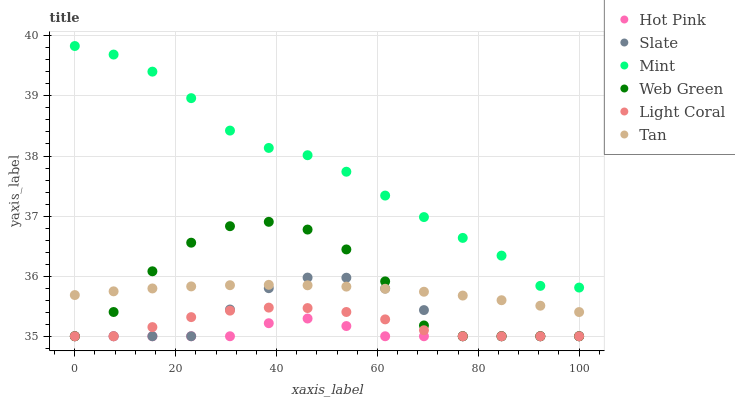Does Hot Pink have the minimum area under the curve?
Answer yes or no. Yes. Does Mint have the maximum area under the curve?
Answer yes or no. Yes. Does Web Green have the minimum area under the curve?
Answer yes or no. No. Does Web Green have the maximum area under the curve?
Answer yes or no. No. Is Tan the smoothest?
Answer yes or no. Yes. Is Web Green the roughest?
Answer yes or no. Yes. Is Hot Pink the smoothest?
Answer yes or no. No. Is Hot Pink the roughest?
Answer yes or no. No. Does Slate have the lowest value?
Answer yes or no. Yes. Does Tan have the lowest value?
Answer yes or no. No. Does Mint have the highest value?
Answer yes or no. Yes. Does Web Green have the highest value?
Answer yes or no. No. Is Hot Pink less than Tan?
Answer yes or no. Yes. Is Mint greater than Web Green?
Answer yes or no. Yes. Does Web Green intersect Tan?
Answer yes or no. Yes. Is Web Green less than Tan?
Answer yes or no. No. Is Web Green greater than Tan?
Answer yes or no. No. Does Hot Pink intersect Tan?
Answer yes or no. No. 